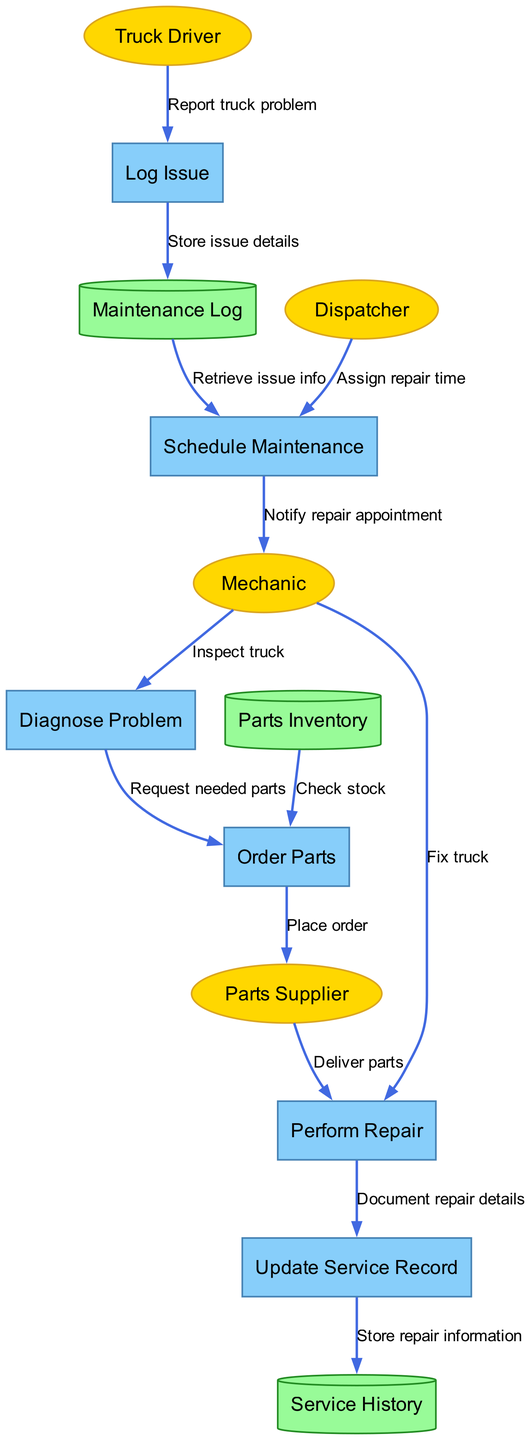What is the first process triggered by a truck driver? The first process is initiated when the Truck Driver reports an issue with the truck. This is indicated in the diagram where the Truck Driver is shown connecting to the Log Issue process with the flow labeled "Report truck problem".
Answer: Log Issue How many external entities are in the diagram? The diagram contains four external entities. These are Truck Driver, Dispatcher, Mechanic, and Parts Supplier, which are represented as separate nodes in the diagram.
Answer: Four What is the final process that updates the service history? The final process that updates the service history is "Update Service Record". This process is connected to the data store Service History, which indicates the completion of documenting the maintenance performed.
Answer: Update Service Record Which process does the Mechanic interact with to diagnose truck problems? The Mechanic interacts with the "Diagnose Problem" process. After performing the inspection of the truck, the Mechanic moves to this next step for diagnosing any issues.
Answer: Diagnose Problem How does the Parts Supplier contribute to the repair process? The Parts Supplier contributes by delivering parts to the "Perform Repair" process, as indicated by the data flow labeled "Deliver parts". This step is crucial for completing the repair work.
Answer: Deliver parts What data store is used to keep track of parts available for ordering? The data store used to keep track of parts available for ordering is "Parts Inventory". This is utilized during the "Order Parts" process to check stock before placing any orders.
Answer: Parts Inventory What action follows the diagnosis of a truck problem? The action that follows the diagnosis of a truck problem is "Order Parts". Once the mechanic diagnoses the issues and identifies the needed parts, the process to order those parts is initiated.
Answer: Order Parts What flows from the Maintenance Log to the Schedule Maintenance process? The flow from the Maintenance Log to the Schedule Maintenance process is labeled "Retrieve issue info". This indicates that details about the truck issues are retrieved to schedule necessary maintenance.
Answer: Retrieve issue info Which two processes are responsible for documenting the repair details? The two processes responsible for documenting the repair details are "Perform Repair" and "Update Service Record". After the repairs are completed, they are documented in the service record for future reference.
Answer: Perform Repair, Update Service Record 